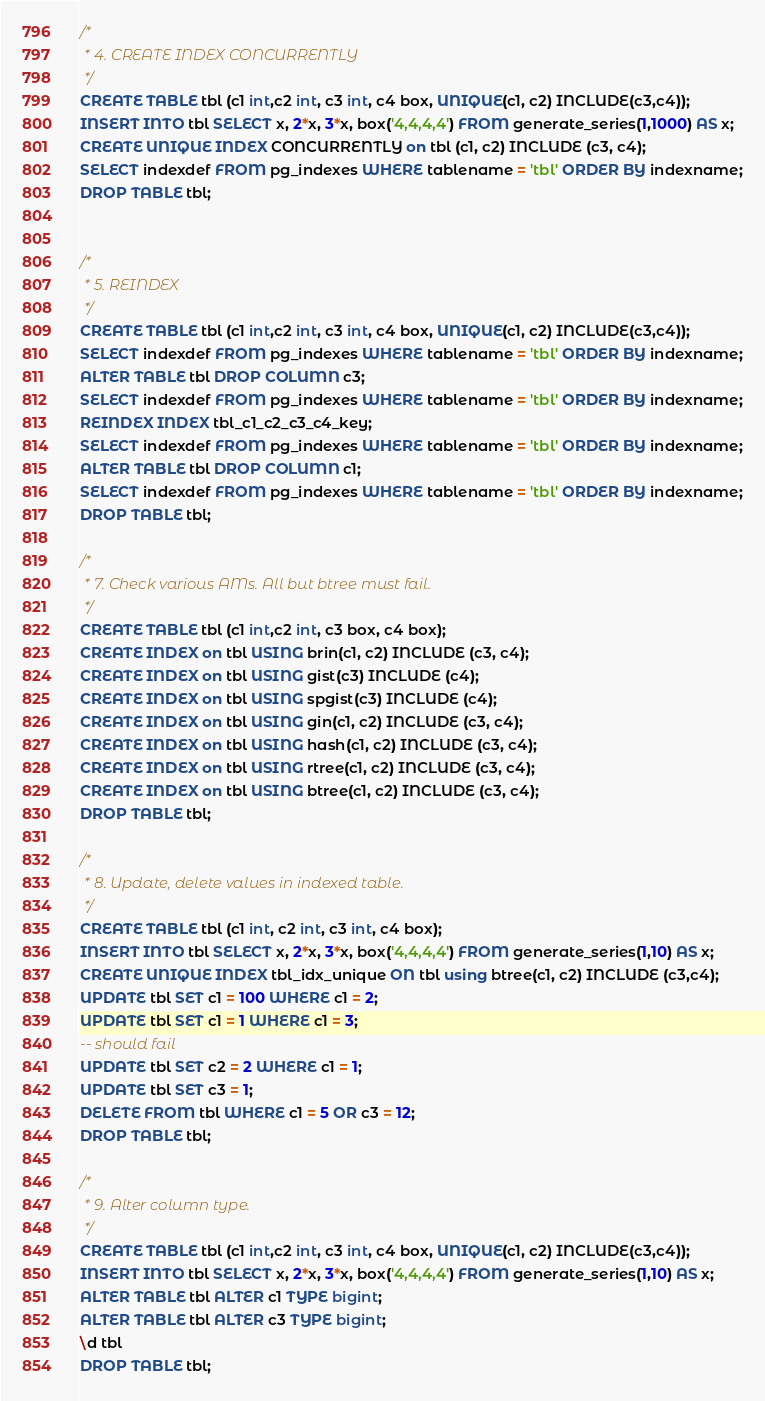Convert code to text. <code><loc_0><loc_0><loc_500><loc_500><_SQL_>/*
 * 4. CREATE INDEX CONCURRENTLY
 */
CREATE TABLE tbl (c1 int,c2 int, c3 int, c4 box, UNIQUE(c1, c2) INCLUDE(c3,c4));
INSERT INTO tbl SELECT x, 2*x, 3*x, box('4,4,4,4') FROM generate_series(1,1000) AS x;
CREATE UNIQUE INDEX CONCURRENTLY on tbl (c1, c2) INCLUDE (c3, c4);
SELECT indexdef FROM pg_indexes WHERE tablename = 'tbl' ORDER BY indexname;
DROP TABLE tbl;


/*
 * 5. REINDEX
 */
CREATE TABLE tbl (c1 int,c2 int, c3 int, c4 box, UNIQUE(c1, c2) INCLUDE(c3,c4));
SELECT indexdef FROM pg_indexes WHERE tablename = 'tbl' ORDER BY indexname;
ALTER TABLE tbl DROP COLUMN c3;
SELECT indexdef FROM pg_indexes WHERE tablename = 'tbl' ORDER BY indexname;
REINDEX INDEX tbl_c1_c2_c3_c4_key;
SELECT indexdef FROM pg_indexes WHERE tablename = 'tbl' ORDER BY indexname;
ALTER TABLE tbl DROP COLUMN c1;
SELECT indexdef FROM pg_indexes WHERE tablename = 'tbl' ORDER BY indexname;
DROP TABLE tbl;

/*
 * 7. Check various AMs. All but btree must fail.
 */
CREATE TABLE tbl (c1 int,c2 int, c3 box, c4 box);
CREATE INDEX on tbl USING brin(c1, c2) INCLUDE (c3, c4);
CREATE INDEX on tbl USING gist(c3) INCLUDE (c4);
CREATE INDEX on tbl USING spgist(c3) INCLUDE (c4);
CREATE INDEX on tbl USING gin(c1, c2) INCLUDE (c3, c4);
CREATE INDEX on tbl USING hash(c1, c2) INCLUDE (c3, c4);
CREATE INDEX on tbl USING rtree(c1, c2) INCLUDE (c3, c4);
CREATE INDEX on tbl USING btree(c1, c2) INCLUDE (c3, c4);
DROP TABLE tbl;

/*
 * 8. Update, delete values in indexed table.
 */
CREATE TABLE tbl (c1 int, c2 int, c3 int, c4 box);
INSERT INTO tbl SELECT x, 2*x, 3*x, box('4,4,4,4') FROM generate_series(1,10) AS x;
CREATE UNIQUE INDEX tbl_idx_unique ON tbl using btree(c1, c2) INCLUDE (c3,c4);
UPDATE tbl SET c1 = 100 WHERE c1 = 2;
UPDATE tbl SET c1 = 1 WHERE c1 = 3;
-- should fail
UPDATE tbl SET c2 = 2 WHERE c1 = 1;
UPDATE tbl SET c3 = 1;
DELETE FROM tbl WHERE c1 = 5 OR c3 = 12;
DROP TABLE tbl;

/*
 * 9. Alter column type.
 */
CREATE TABLE tbl (c1 int,c2 int, c3 int, c4 box, UNIQUE(c1, c2) INCLUDE(c3,c4));
INSERT INTO tbl SELECT x, 2*x, 3*x, box('4,4,4,4') FROM generate_series(1,10) AS x;
ALTER TABLE tbl ALTER c1 TYPE bigint;
ALTER TABLE tbl ALTER c3 TYPE bigint;
\d tbl
DROP TABLE tbl;

</code> 